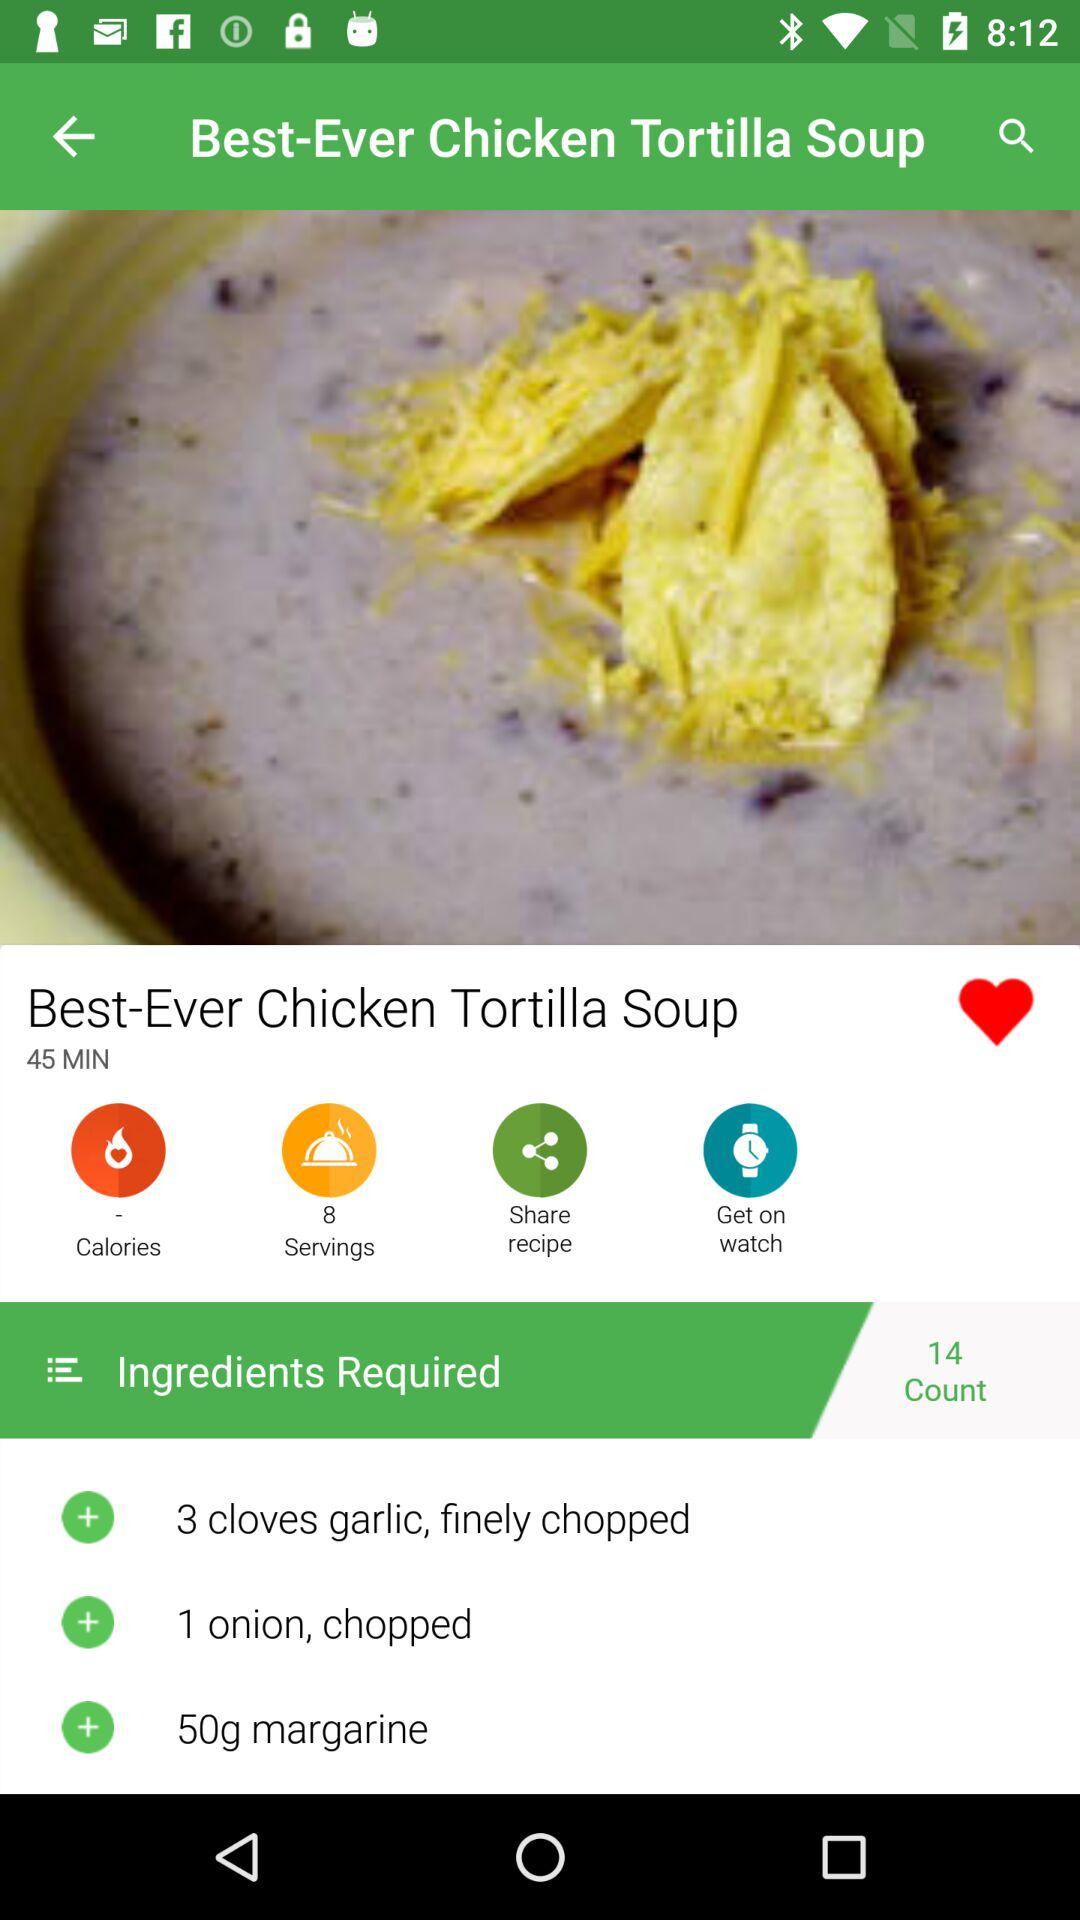How many servings does this recipe make?
Answer the question using a single word or phrase. 8 